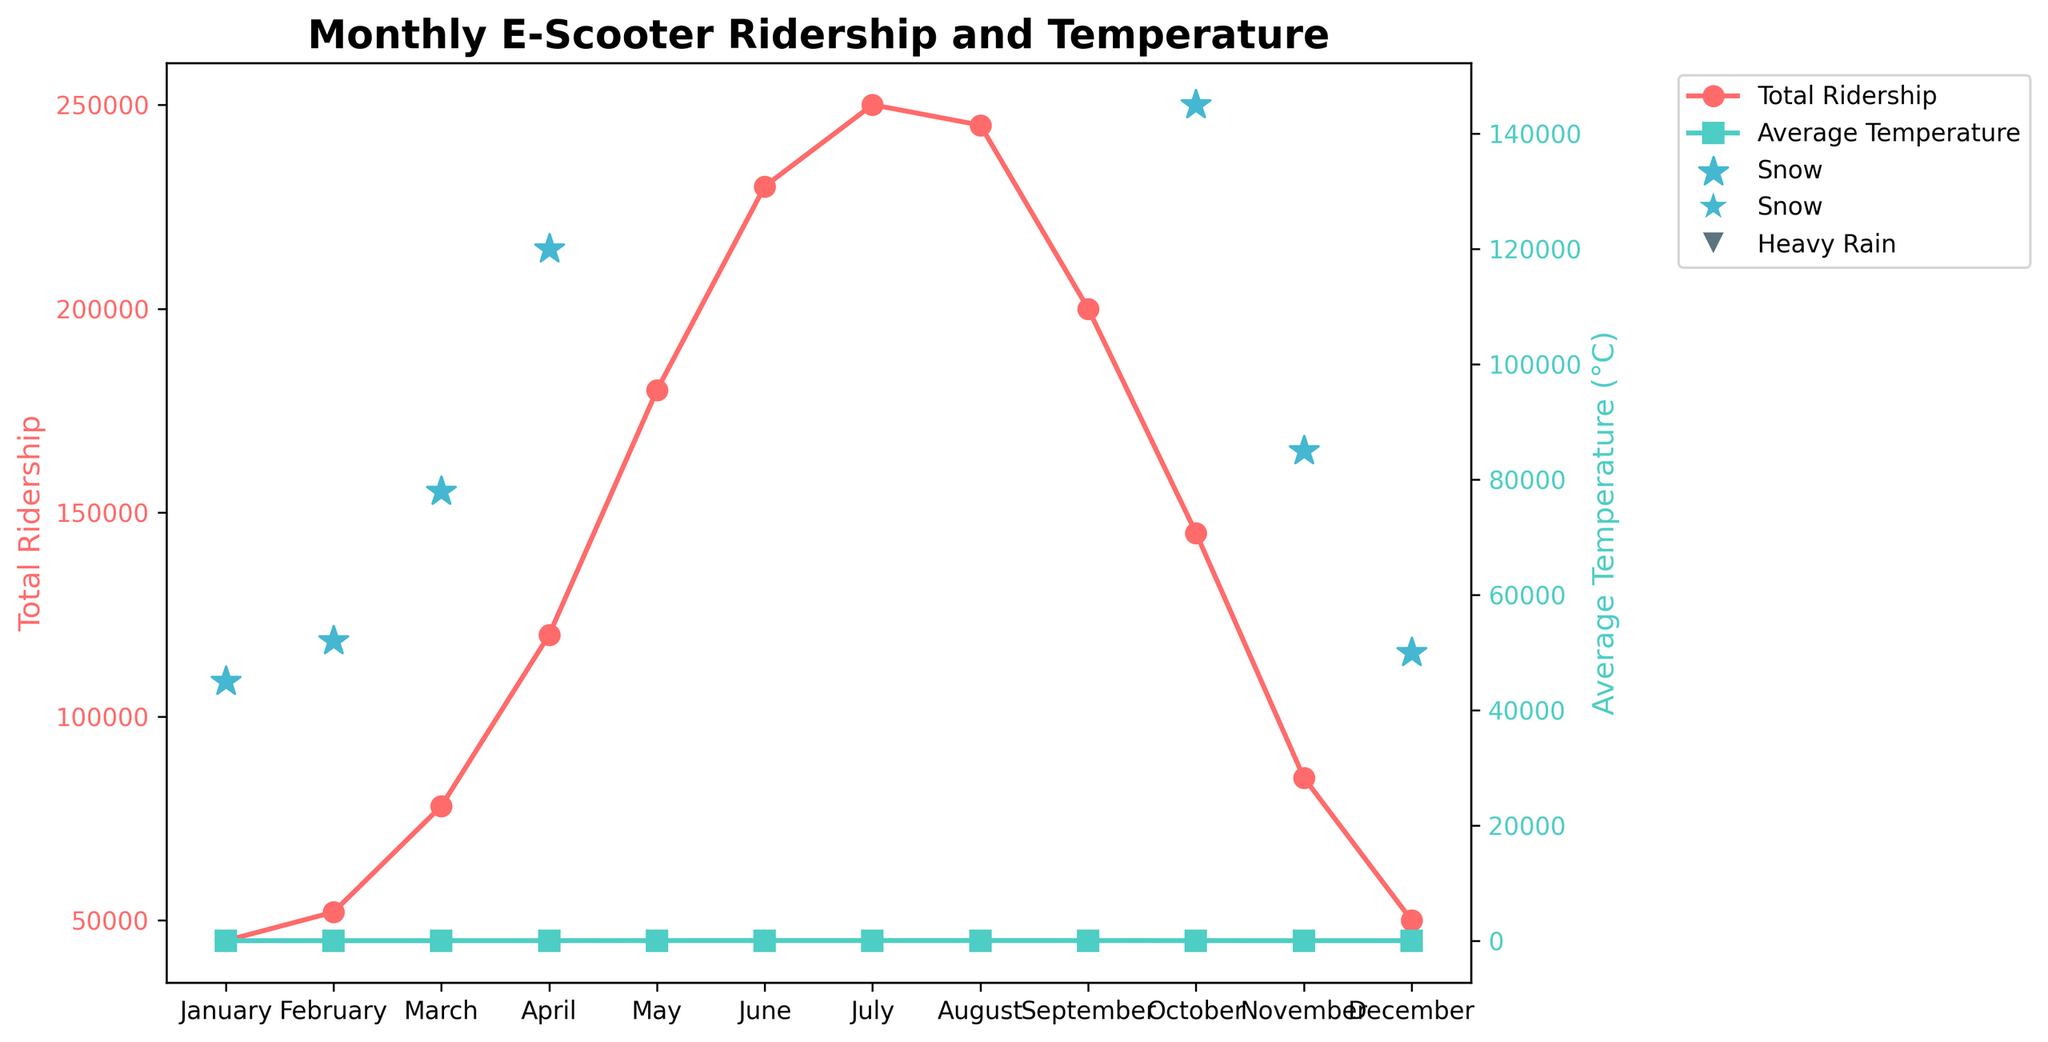Which month has the highest ridership? Observe the line representing Total Ridership and find the peak point. The peak point occurs in July.
Answer: July Which months have snowfall? Look for the star markers which indicate snowfall on the plotted figure. The months with star markers are January, February, March, October, November, December.
Answer: January, February, March, October, November, December How does ridership in June compare to that in October? Locate the points on the line representing Total Ridership for June and October. June has a ridership of 230,000 while October has 145,000. Since 230,000 > 145,000, ridership in June is higher.
Answer: Higher in June Is there a month with both heavy rain and snowfall? Identify the markers for Heavy Rain and Snow on the plot. November has both the triangle marker for Heavy Rain and star marker for Snow.
Answer: November What is the total ridership for the first quarter of the year? Sum the Total Ridership values for January, February, and March. The values are 45,000 + 52,000 + 78,000, which equals 175,000.
Answer: 175,000 How does the average temperature in December compare to that in January? Compare the points on the line representing Average Temperature for December and January. January has an average temperature of -2°C and December has 2°C. Since 2°C > -2°C, December is warmer.
Answer: Warmer in December What visual pattern emerges when comparing Average Temperature and Total Ridership? Assess the two lines plotted—one for Total Ridership and one for Average Temperature. Both lines increase from January to peak around mid-year and decrease afterward, showing that ridership and temperature rise and fall together.
Answer: Both increase and decrease together Is there any month where the temperature is the highest but ridership is not the highest? Identify the peak points of both lines. Temperature peaks in July at 25°C, which is also the peak month for ridership, hence, no such month fits the criteria.
Answer: No In which months did the ridership exceed 200,000? Locate the points on the Total Ridership line that are above 200,000. The months are June, July, and August.
Answer: June, July, August How does ridership change from June to July? Examine the points on the Total Ridership line for June and July. June has 230,000 and July has 250,000, so ridership increases.
Answer: Increases 